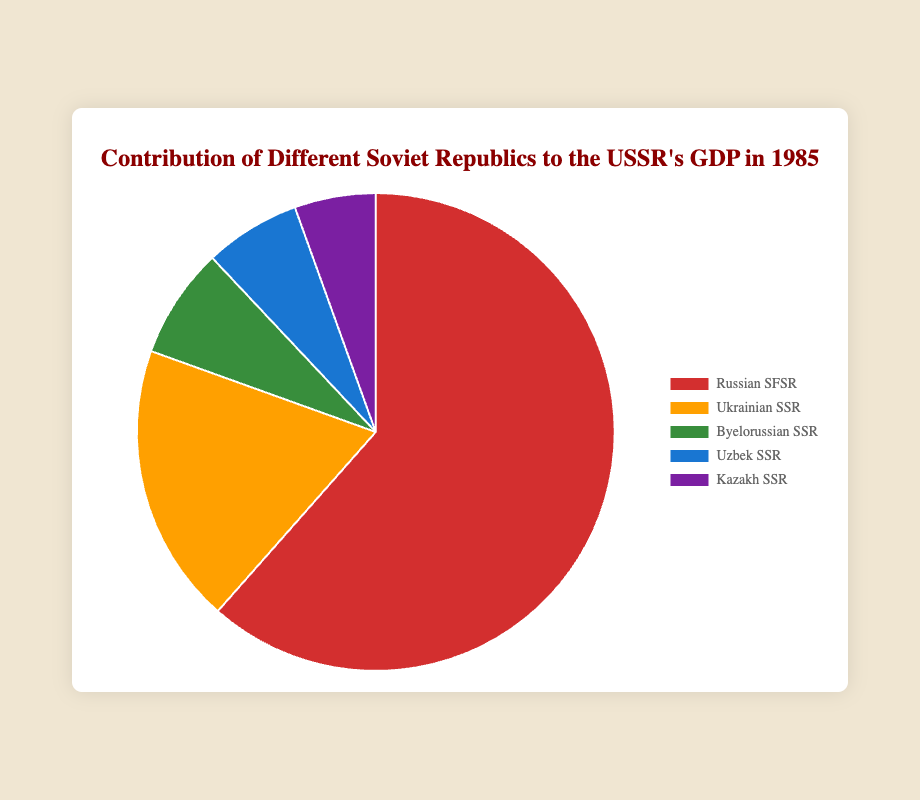Which republic contributed the most to the USSR's GDP in 1985? The pie chart clearly shows that the largest section corresponds to the Russian SFSR.
Answer: Russian SFSR What is the combined GDP contribution of the Byelorussian SSR and Kazakh SSR? Sum the GDP values of Byelorussian SSR (150) and Kazakh SSR (110). Thus, 150 + 110 = 260.
Answer: 260 How does the GDP contribution of the Ukrainian SSR compare to that of the Uzbek SSR? The GDP contribution of the Ukrainian SSR is 380, and the Uzbek SSR is 130. Since 380 is greater than 130, the Ukrainian SSR contributed more.
Answer: Ukrainian SSR contributed more What percentage of the total GDP did the Russian SFSR contribute, assuming the sum of all presented contributions? The total GDP is 1230 + 380 + 150 + 130 + 110 = 2000. The percentage is (1230 / 2000) * 100 = 61.5%.
Answer: 61.5% Which republic contributed the second least to the GDP, and how much did it contribute? The second least contribution is from the Uzbek SSR with 130 billion rubles, higher than the Kazakh SSR and lower than the Byelorussian SSR.
Answer: Uzbek SSR, 130 billion rubles What is the difference in GDP contributions between the highest and the lowest contributing republics? Subtract the GDP of the lowest contributing republic (Kazakh SSR, 110) from the highest (Russian SFSR, 1230). Thus, 1230 - 110 = 1120.
Answer: 1120 How does the combined GDP of the Ukrainian SSR and Byelorussian SSR compare to the GDP of the Russian SFSR? The combined GDP of Ukrainian SSR and Byelorussian SSR is 380 + 150 = 530. Comparing this to the Russian SFSR's 1230, 1230 is significantly greater than 530.
Answer: Russian SFSR contributed more Which color corresponds to the Kazakh SSR in the pie chart, and what significance might this have? The Kazakh SSR is represented by the purple segment in the pie chart. The colors are generally used to visually distinguish different sections, but the specific color choice does not carry inherent significance beyond differentiation.
Answer: Purple, no inherent significance beyond differentiation What fraction of the total GDP is contributed by the Uzbek SSR? The total GDP is 2000 and the Uzbek SSR contributes 130. The fraction is 130/2000, which simplifies to 13/200 or 6.5%.
Answer: 6.5% 